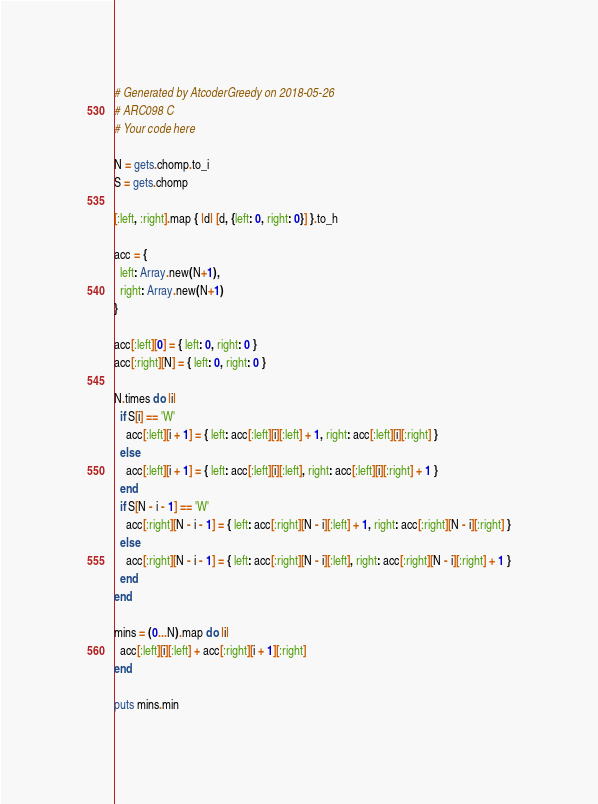Convert code to text. <code><loc_0><loc_0><loc_500><loc_500><_Ruby_># Generated by AtcoderGreedy on 2018-05-26
# ARC098 C
# Your code here

N = gets.chomp.to_i
S = gets.chomp

[:left, :right].map { |d| [d, {left: 0, right: 0}] }.to_h

acc = {
  left: Array.new(N+1),
  right: Array.new(N+1)
}

acc[:left][0] = { left: 0, right: 0 }
acc[:right][N] = { left: 0, right: 0 }

N.times do |i|
  if S[i] == 'W'
    acc[:left][i + 1] = { left: acc[:left][i][:left] + 1, right: acc[:left][i][:right] }
  else
    acc[:left][i + 1] = { left: acc[:left][i][:left], right: acc[:left][i][:right] + 1 }
  end
  if S[N - i - 1] == 'W'
    acc[:right][N - i - 1] = { left: acc[:right][N - i][:left] + 1, right: acc[:right][N - i][:right] }
  else
    acc[:right][N - i - 1] = { left: acc[:right][N - i][:left], right: acc[:right][N - i][:right] + 1 }
  end
end

mins = (0...N).map do |i|
  acc[:left][i][:left] + acc[:right][i + 1][:right]
end

puts mins.min
</code> 